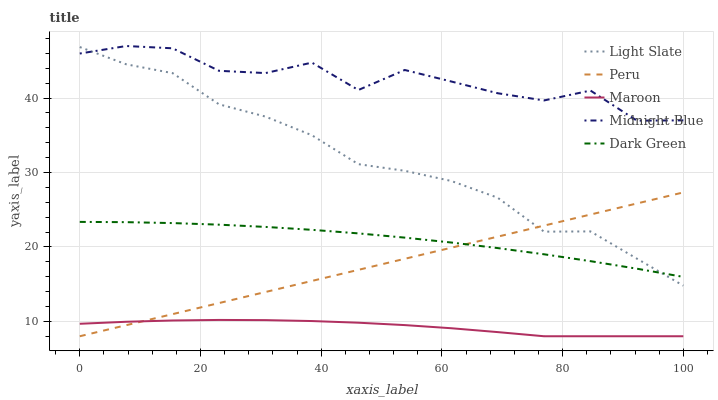Does Maroon have the minimum area under the curve?
Answer yes or no. Yes. Does Midnight Blue have the maximum area under the curve?
Answer yes or no. Yes. Does Dark Green have the minimum area under the curve?
Answer yes or no. No. Does Dark Green have the maximum area under the curve?
Answer yes or no. No. Is Peru the smoothest?
Answer yes or no. Yes. Is Midnight Blue the roughest?
Answer yes or no. Yes. Is Dark Green the smoothest?
Answer yes or no. No. Is Dark Green the roughest?
Answer yes or no. No. Does Dark Green have the lowest value?
Answer yes or no. No. Does Dark Green have the highest value?
Answer yes or no. No. Is Maroon less than Dark Green?
Answer yes or no. Yes. Is Dark Green greater than Maroon?
Answer yes or no. Yes. Does Maroon intersect Dark Green?
Answer yes or no. No. 